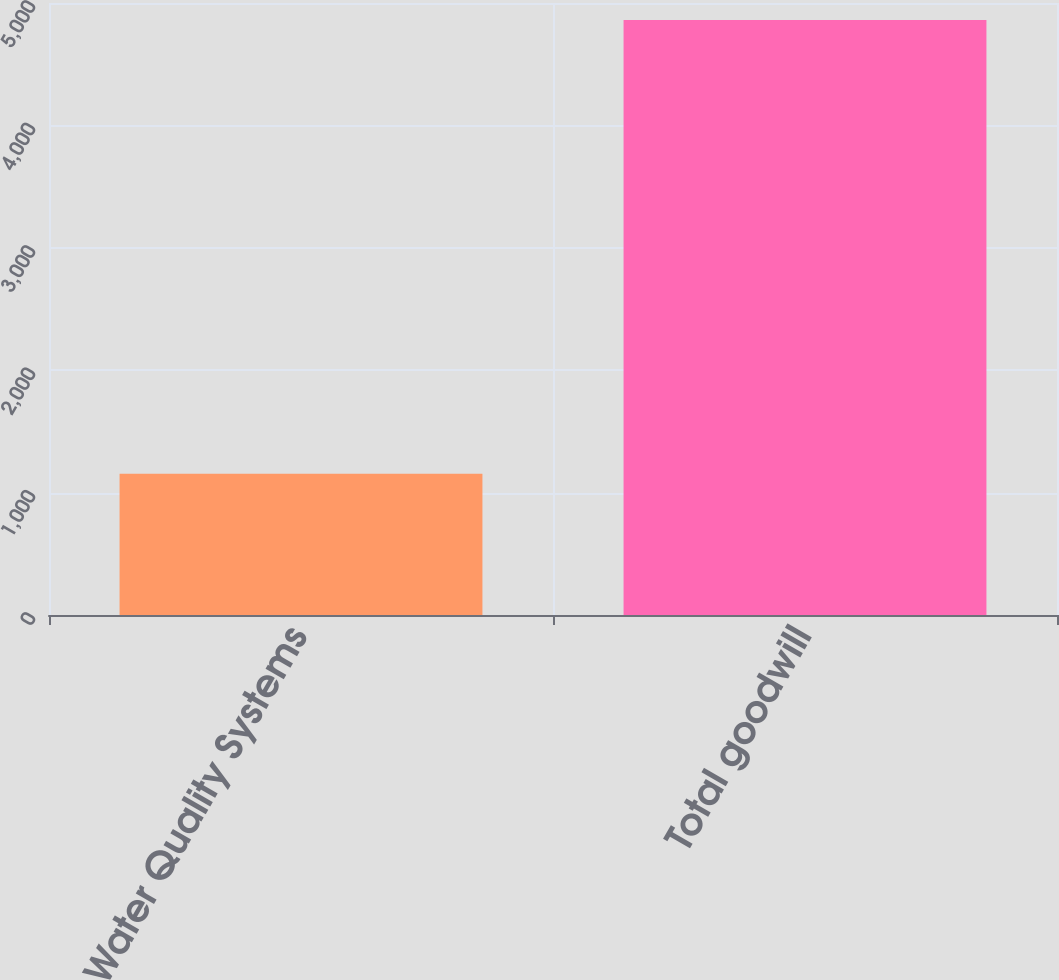Convert chart to OTSL. <chart><loc_0><loc_0><loc_500><loc_500><bar_chart><fcel>Water Quality Systems<fcel>Total goodwill<nl><fcel>1154.7<fcel>4860.7<nl></chart> 